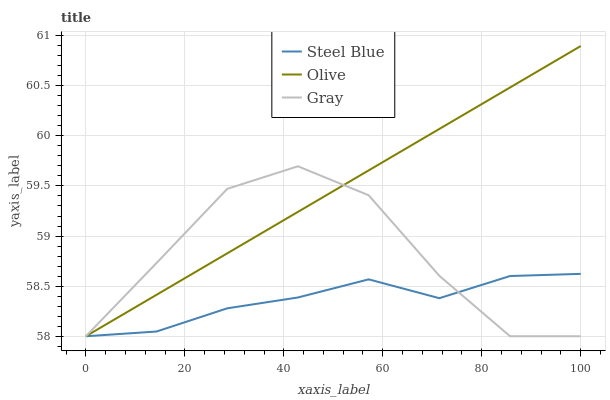Does Steel Blue have the minimum area under the curve?
Answer yes or no. Yes. Does Olive have the maximum area under the curve?
Answer yes or no. Yes. Does Gray have the minimum area under the curve?
Answer yes or no. No. Does Gray have the maximum area under the curve?
Answer yes or no. No. Is Olive the smoothest?
Answer yes or no. Yes. Is Gray the roughest?
Answer yes or no. Yes. Is Steel Blue the smoothest?
Answer yes or no. No. Is Steel Blue the roughest?
Answer yes or no. No. Does Olive have the lowest value?
Answer yes or no. Yes. Does Olive have the highest value?
Answer yes or no. Yes. Does Gray have the highest value?
Answer yes or no. No. Does Olive intersect Steel Blue?
Answer yes or no. Yes. Is Olive less than Steel Blue?
Answer yes or no. No. Is Olive greater than Steel Blue?
Answer yes or no. No. 